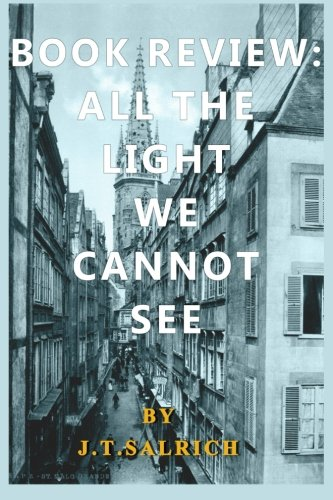Is this a judicial book? No, this book is not related to law or judiciary matters; it belongs to the genre of Literature & Fiction. 